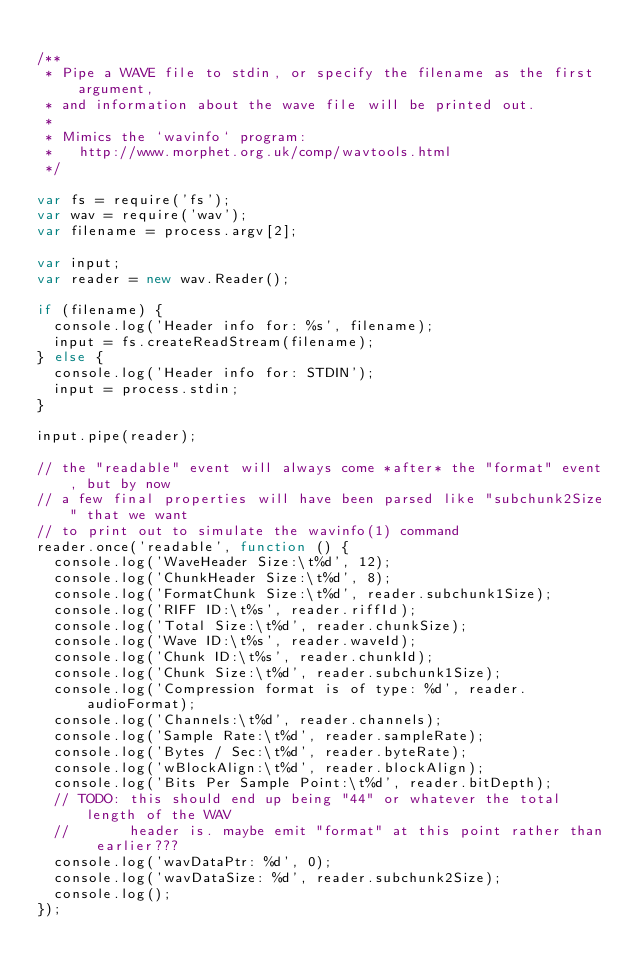<code> <loc_0><loc_0><loc_500><loc_500><_JavaScript_>
/**
 * Pipe a WAVE file to stdin, or specify the filename as the first argument,
 * and information about the wave file will be printed out.
 *
 * Mimics the `wavinfo` program:
 *   http://www.morphet.org.uk/comp/wavtools.html
 */

var fs = require('fs');
var wav = require('wav');
var filename = process.argv[2];

var input;
var reader = new wav.Reader();

if (filename) {
  console.log('Header info for: %s', filename);
  input = fs.createReadStream(filename);
} else {
  console.log('Header info for: STDIN');
  input = process.stdin;
}

input.pipe(reader);

// the "readable" event will always come *after* the "format" event, but by now
// a few final properties will have been parsed like "subchunk2Size" that we want
// to print out to simulate the wavinfo(1) command
reader.once('readable', function () {
  console.log('WaveHeader Size:\t%d', 12);
  console.log('ChunkHeader Size:\t%d', 8);
  console.log('FormatChunk Size:\t%d', reader.subchunk1Size);
  console.log('RIFF ID:\t%s', reader.riffId);
  console.log('Total Size:\t%d', reader.chunkSize);
  console.log('Wave ID:\t%s', reader.waveId);
  console.log('Chunk ID:\t%s', reader.chunkId);
  console.log('Chunk Size:\t%d', reader.subchunk1Size);
  console.log('Compression format is of type: %d', reader.audioFormat);
  console.log('Channels:\t%d', reader.channels);
  console.log('Sample Rate:\t%d', reader.sampleRate);
  console.log('Bytes / Sec:\t%d', reader.byteRate);
  console.log('wBlockAlign:\t%d', reader.blockAlign);
  console.log('Bits Per Sample Point:\t%d', reader.bitDepth);
  // TODO: this should end up being "44" or whatever the total length of the WAV
  //       header is. maybe emit "format" at this point rather than earlier???
  console.log('wavDataPtr: %d', 0);
  console.log('wavDataSize: %d', reader.subchunk2Size);
  console.log();
});</code> 